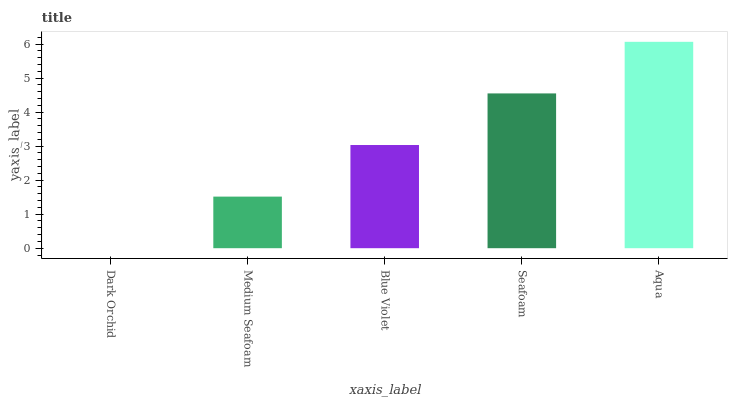Is Dark Orchid the minimum?
Answer yes or no. Yes. Is Aqua the maximum?
Answer yes or no. Yes. Is Medium Seafoam the minimum?
Answer yes or no. No. Is Medium Seafoam the maximum?
Answer yes or no. No. Is Medium Seafoam greater than Dark Orchid?
Answer yes or no. Yes. Is Dark Orchid less than Medium Seafoam?
Answer yes or no. Yes. Is Dark Orchid greater than Medium Seafoam?
Answer yes or no. No. Is Medium Seafoam less than Dark Orchid?
Answer yes or no. No. Is Blue Violet the high median?
Answer yes or no. Yes. Is Blue Violet the low median?
Answer yes or no. Yes. Is Seafoam the high median?
Answer yes or no. No. Is Dark Orchid the low median?
Answer yes or no. No. 